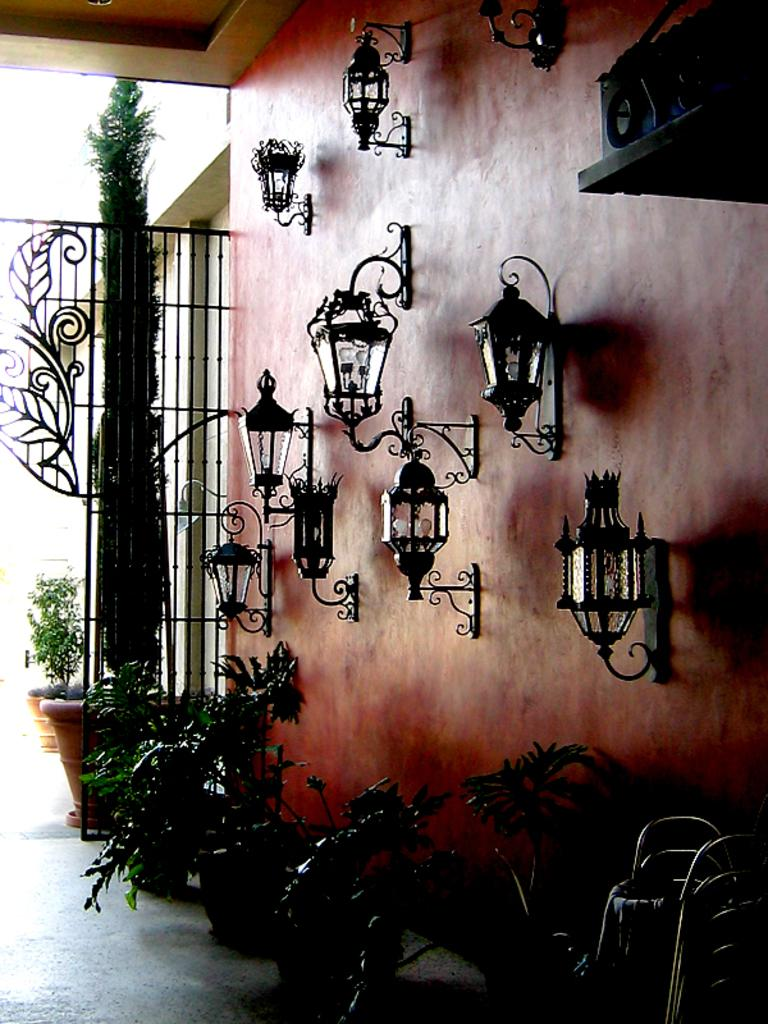What is attached to the wall in the image? There are lights fitted to the wall in the image. What is placed in front of the wall in the image? There are plants in front of the wall in the image. What can be seen in the background of the image? There is an iron grill in the background of the image. How many plants are visible behind the iron grill in the image? There are two plants behind the iron grill in the image. What time is displayed on the clock in the image? There is no clock present in the image; it only features lights, plants, and an iron grill. What type of beef is being cooked in the image? There is no beef or any cooking activity present in the image. 